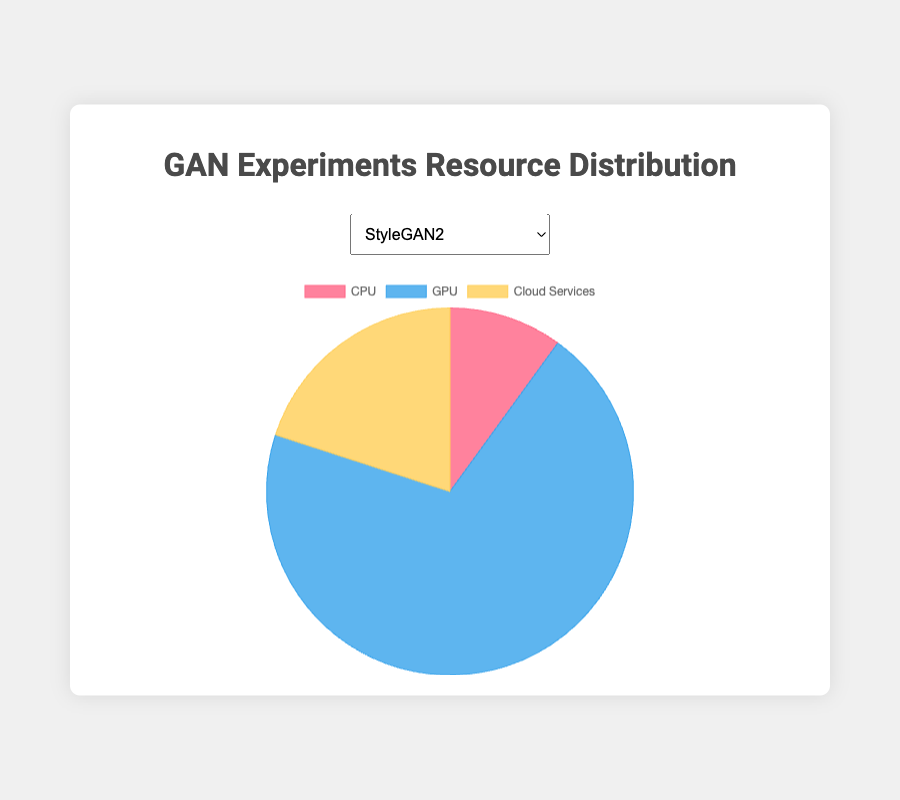Which experiment utilizes the most GPU resources? By examining each experiment's GPU distribution, we observe that 'BigGAN' has the highest usage at 80%.
Answer: BigGAN What is the average percentage of CPU resources used across all experiments? The CPU percentages are 10, 20, 5, 30, and 15. Adding these gives 80. Dividing by 5 (number of experiments) gives 80/5 = 16%.
Answer: 16% How much more GPU resource does StyleGAN2 utilize compared to DCGAN? StyleGAN2 uses 70% and DCGAN uses 50%, so the difference is 70% - 50% = 20%.
Answer: 20% Which resource type is least utilized in CycleGAN experiments? By examining CycleGAN's resource distribution: CPU (20%), GPU (65%), and Cloud Services (15%), Cloud Services has the lowest value.
Answer: Cloud Services What is the range of Cloud Services usage across all experiments? Looking at Cloud Services percentages: 20, 15, 15, 20, and 25, the highest is 25 and the lowest is 15, so the range is 25 - 15 = 10%.
Answer: 10% Compare the Cloud Services usage between Pix2Pix and StyleGAN2. Pix2Pix uses 25% and StyleGAN2 uses 20%, so Pix2Pix uses 5% more Cloud Services than StyleGAN2.
Answer: 5% Which experiments have an equal allocation of Cloud Services? Both StyleGAN2 and DCGAN allocate 20% of resources to Cloud Services.
Answer: StyleGAN2 and DCGAN What is the total percentage of GPU usage across all experiments? Summing all GPU percentages: 70, 65, 80, 50, and 60 gives 325%.
Answer: 325% How does the CPU usage in BigGAN compare to Pix2Pix? BigGAN's CPU usage is 5%, while Pix2Pix's is 15%, so Pix2Pix uses 10% more CPU resources.
Answer: 10% In which experiment is the distribution between GPU and Cloud Services an exact 80/20 split? By assessing each experiment, 'BigGAN' precisely follows an 80% GPU and 20% other resource (which can be CPU/Cloud Services) split for GPU.
Answer: BigGAN 